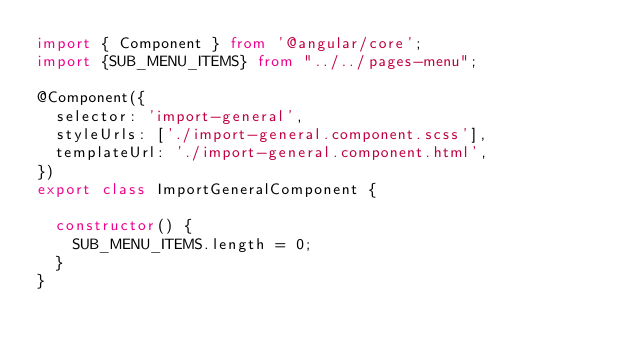Convert code to text. <code><loc_0><loc_0><loc_500><loc_500><_TypeScript_>import { Component } from '@angular/core';
import {SUB_MENU_ITEMS} from "../../pages-menu";

@Component({
  selector: 'import-general',
  styleUrls: ['./import-general.component.scss'],
  templateUrl: './import-general.component.html',
})
export class ImportGeneralComponent {

  constructor() {
    SUB_MENU_ITEMS.length = 0;
  }
}
</code> 